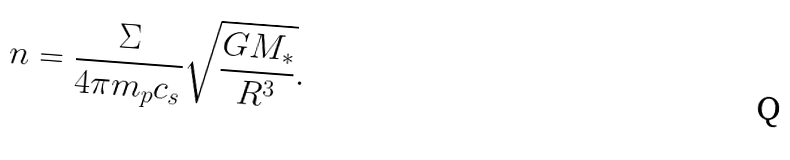<formula> <loc_0><loc_0><loc_500><loc_500>n = \frac { \Sigma } { 4 \pi m _ { p } c _ { s } } \sqrt { \frac { G M _ { * } } { R ^ { 3 } } } .</formula> 